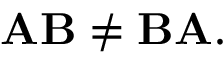<formula> <loc_0><loc_0><loc_500><loc_500>A B \neq B A .</formula> 